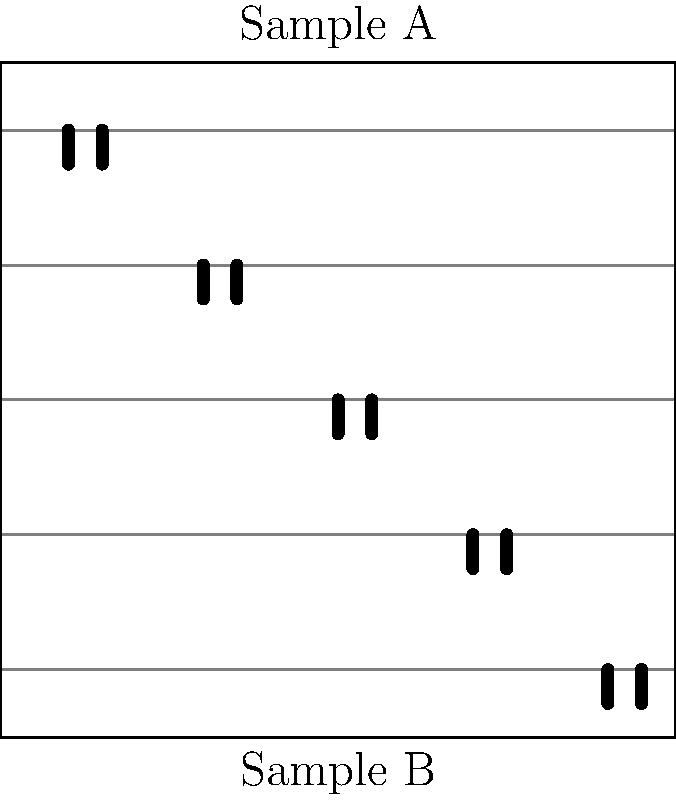In a gel electrophoresis experiment comparing DNA fragment patterns from two samples, the results are shown in the image above. Based on this evidence, what can be concluded about the relationship between Sample A and Sample B? To analyze the relationship between Sample A and Sample B, we need to compare their DNA fragment patterns:

1. Number of bands: Both samples have 5 distinct bands, indicating a similar number of DNA fragments.

2. Band positions: The positions of the bands are slightly offset but follow a similar pattern. This suggests that the fragments have similar sizes but are not identical.

3. Migration distance: Sample B's bands have migrated slightly further than Sample A's. This could be due to small differences in fragment sizes or experimental conditions.

4. Overall pattern: The general pattern of band distribution is very similar between the two samples, suggesting a close relationship.

5. Differences: While similar, the patterns are not identical. This indicates that there are some genetic differences between the samples.

Given these observations, we can conclude that Sample A and Sample B are likely from closely related individuals or populations, but not identical. This pattern is consistent with what might be seen when comparing DNA from family members or individuals from the same species but different populations.

It's important to note that without additional context or controls, we cannot make definitive statements about the exact relationship. However, the evidence strongly suggests a close genetic relationship with some differences.
Answer: Closely related but not identical 